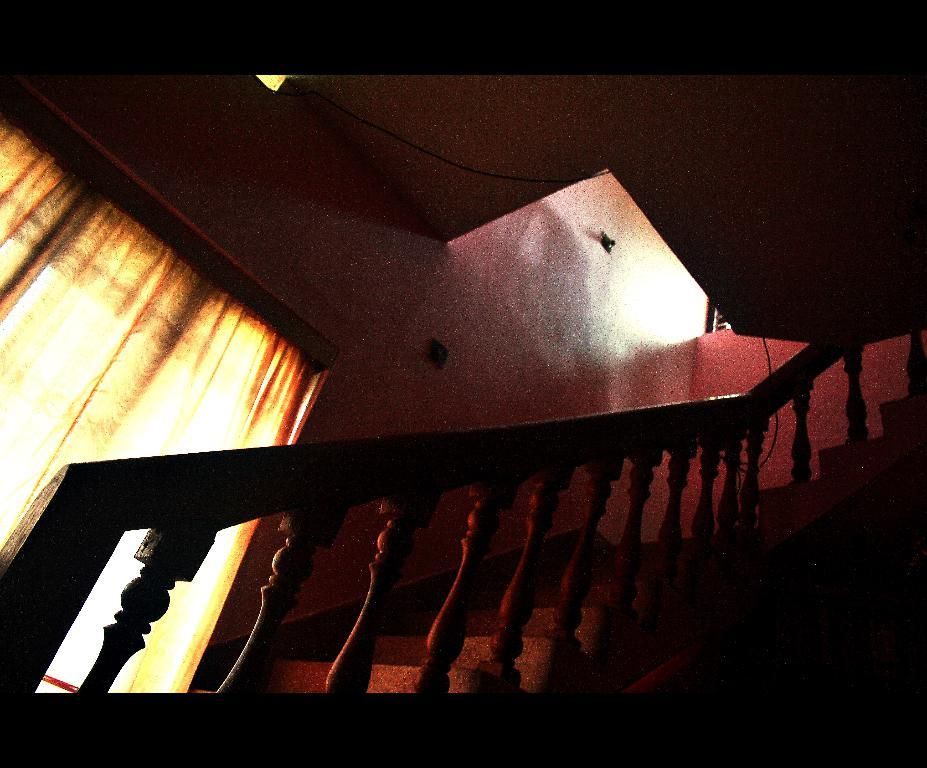What type of structure is present in the image? There is a staircase in the image. Where is the window located in the image? The window is on the left side of the image. What is covering the window? The window is covered with a curtain. What can be seen in the background of the image? There is a wall visible in the background of the image. What type of goat can be seen climbing the staircase in the image? There is no goat present in the image, and therefore no such activity can be observed. 